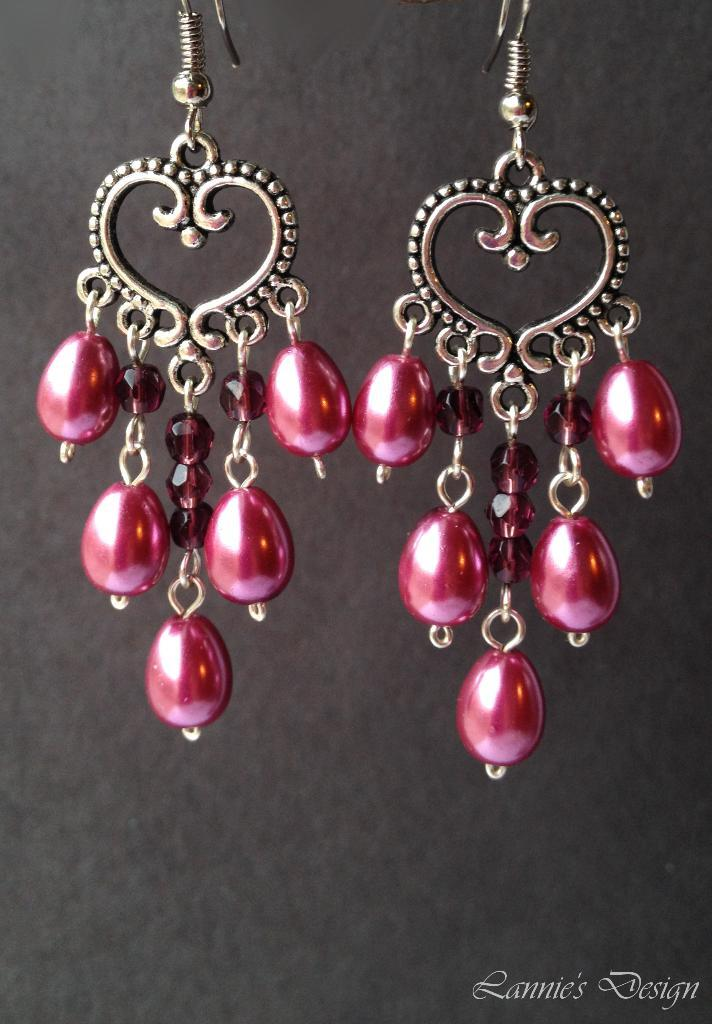What type of accessory is featured in the image? There is a pair of earrings in the image. What material are the earrings made of? The earrings are made with red beads. What is the outcome of the competition depicted in the image? There is no competition present in the image; it features a pair of earrings made with red beads. 